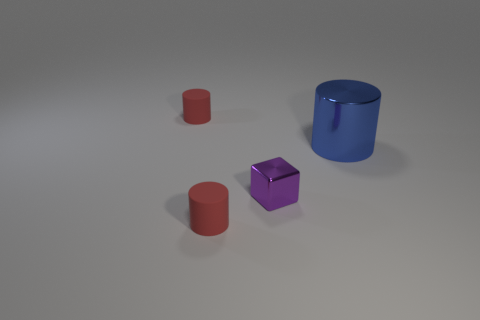Add 1 matte cylinders. How many objects exist? 5 Subtract all cubes. How many objects are left? 3 Subtract all big green metal things. Subtract all small rubber objects. How many objects are left? 2 Add 1 big blue things. How many big blue things are left? 2 Add 4 blue cylinders. How many blue cylinders exist? 5 Subtract 0 cyan blocks. How many objects are left? 4 